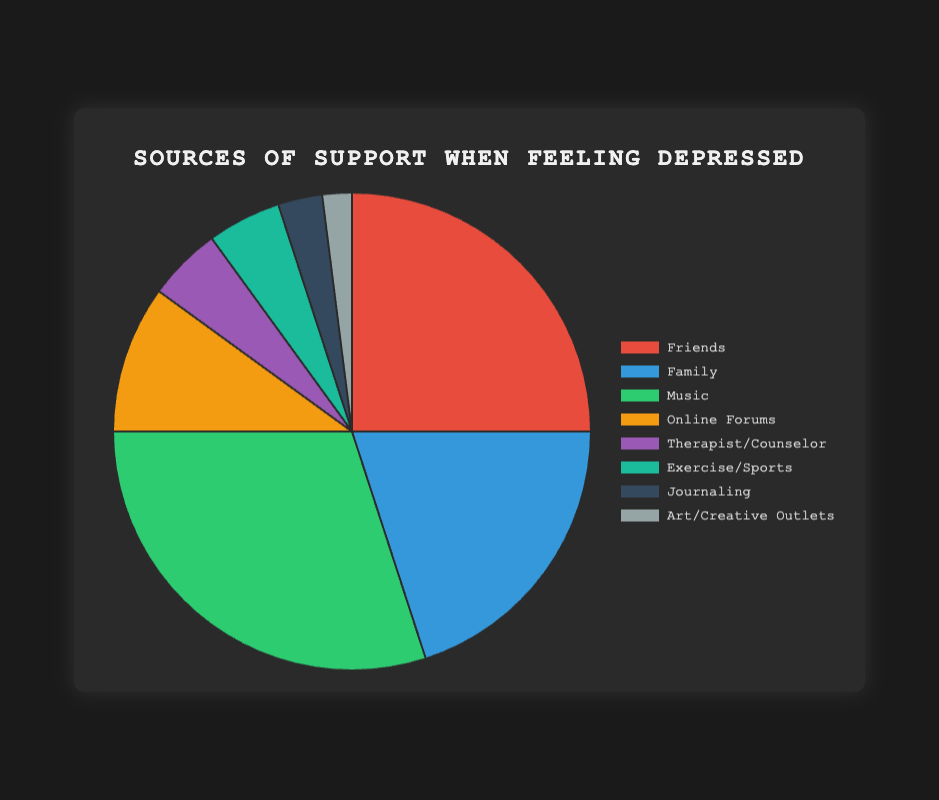what's the most common source of support? Looking at the pie chart, identify the segment that has the largest percentage. This is labeled as "Music" with 30%.
Answer: Music which sources of support have the same percentage? On the pie chart, observe the segments with the same size. Both "Therapist/Counselor" and "Exercise/Sports" each have 5%.
Answer: Therapist/Counselor, Exercise/Sports how much more do I rely on music compared to online forums? From the pie chart, Music is 30% and Online Forums is 10%. The difference is 30% - 10% = 20%.
Answer: 20% if friends and family are considered together, what percentage of support do they provide? Add the percentages of "Friends" and "Family" from the pie chart. Friends (25%) + Family (20%) = 45%.
Answer: 45% which source of support is less preferred: journaling or art/creative outlets? Compare the percentages of "Journaling" and "Art/Creative Outlets" on the pie chart. Journaling is 3%, and Art/Creative Outlets is 2%. 2% is less than 3%.
Answer: Art/Creative Outlets what is the combined percentage of less common sources of support under 10% each? Add up the percentages less than 10%: Online Forums (10%), Therapist/Counselor (5%), Exercise/Sports (5%), Journaling (3%), Art/Creative Outlets (2%). 10% + 5% + 5% + 3% + 2% = 25%.
Answer: 25% what color represents family as a source of support? Look at the legend next to "Family" to identify the color. The color associated with Family is blue.
Answer: Blue 